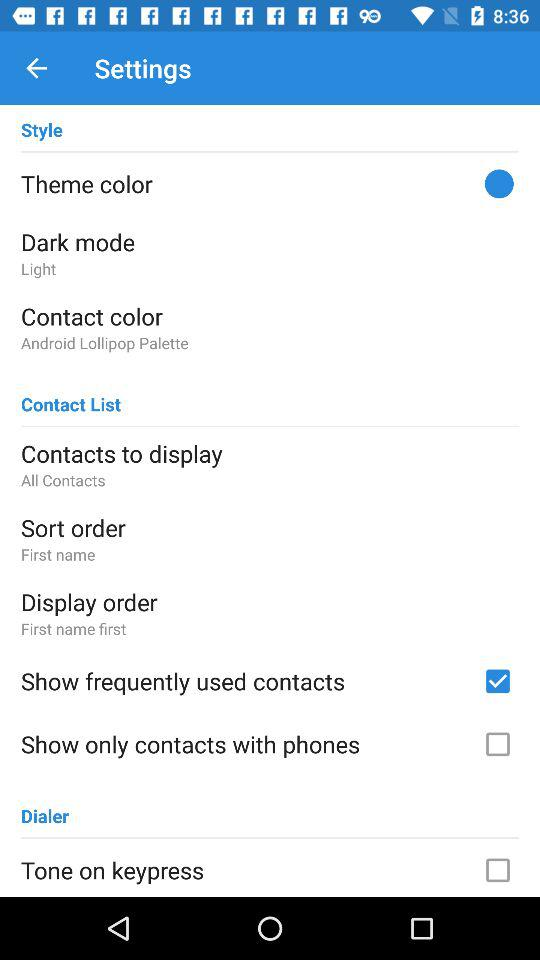What is the status of the "Show frequently used contacts" setting? The status of the "Show frequently used contacts" setting is "on". 